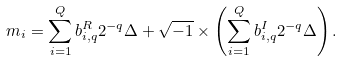Convert formula to latex. <formula><loc_0><loc_0><loc_500><loc_500>m _ { i } = \sum _ { i = 1 } ^ { Q } b ^ { R } _ { i , q } 2 ^ { - q } \Delta + \sqrt { - 1 } \times \left ( \sum _ { i = 1 } ^ { Q } b ^ { I } _ { i , q } 2 ^ { - q } \Delta \right ) .</formula> 